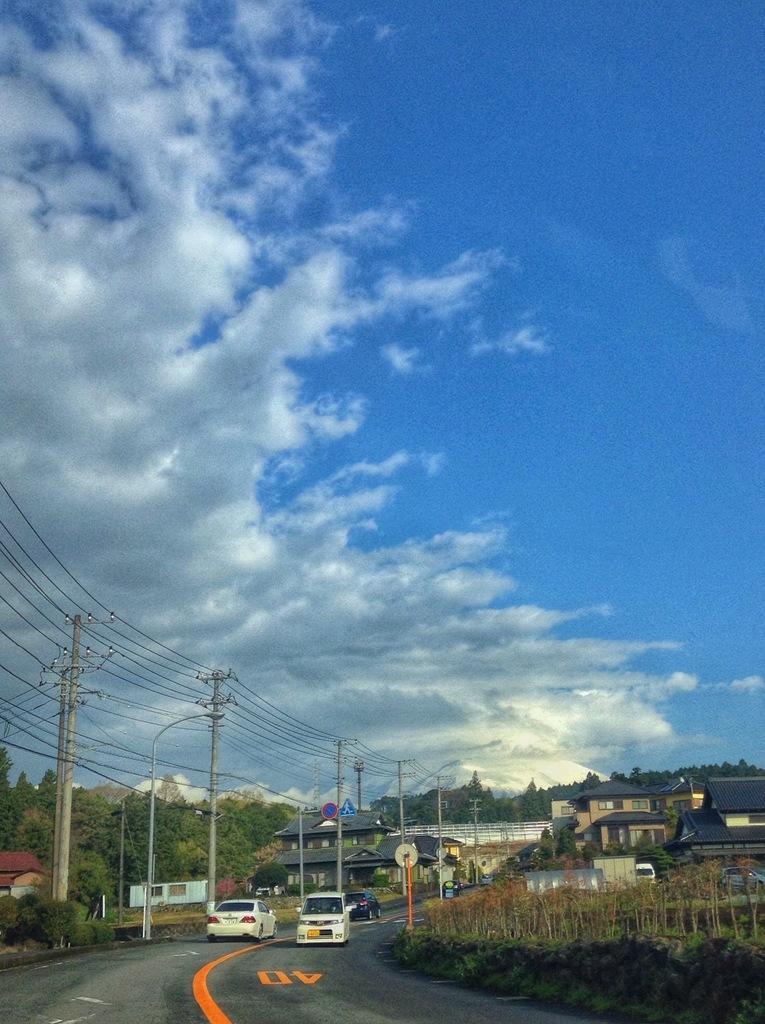Can you describe this image briefly? In this image we can see vehicles on the road. There are electric poles with wires. In the back there are buildings. Also there are trees. In the background there is sky with clouds. 